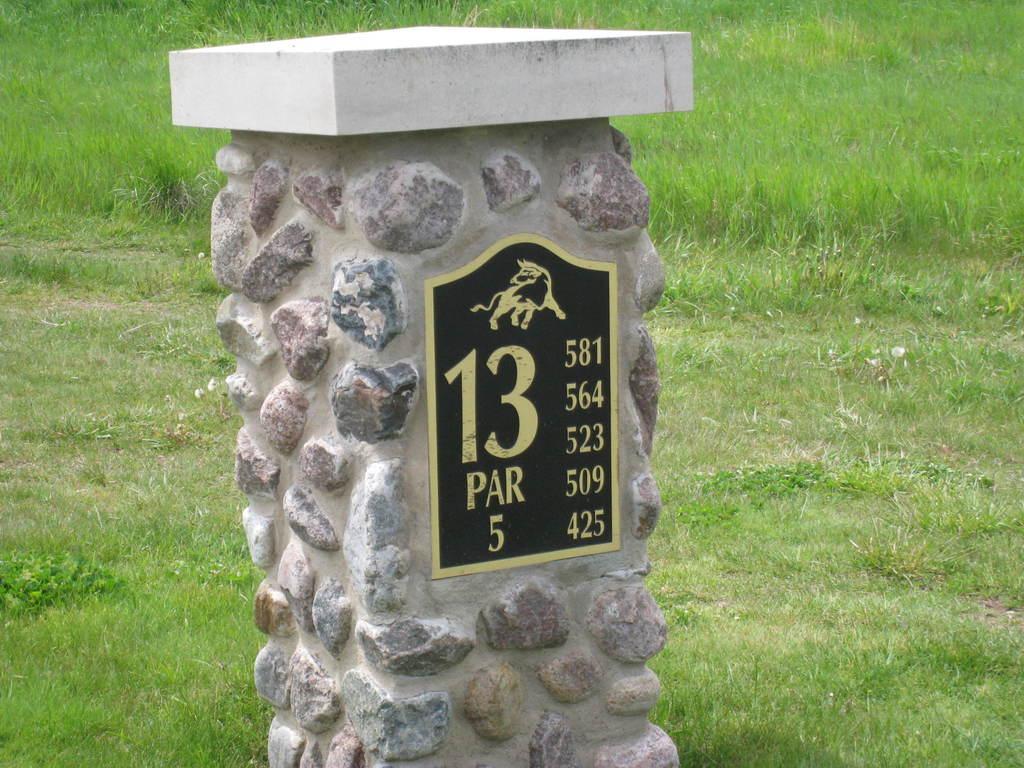How would you summarize this image in a sentence or two? In this image I can see a stone stand and on it I can see something is written over here. In the background I can see green grass. 